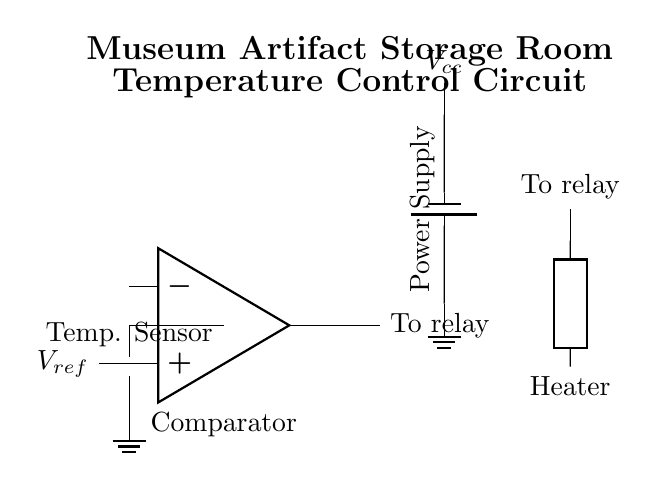What is the main function of the circuit? The circuit is designed to regulate temperature in a museum's artifact storage room, ensuring that the environmental conditions are suitable for preserving the artifacts.
Answer: Regulate temperature What type of sensor is used in this circuit? The circuit employs a thermistor as a temperature sensor, which changes resistance based on the temperature it experiences.
Answer: Thermistor What is the reference voltage designated in the circuit? The reference voltage is indicated as V ref in the circuit, which is used by the comparator to determine if the current temperature exceeds the desired threshold.
Answer: V ref What component controls the heating element? The comparator output ultimately controls the relay, which acts as a switch to turn the heating element on or off based on temperature readings.
Answer: Relay What is the role of the operational amplifier in this circuit? The operational amplifier functions as a comparator, comparing the voltage from the thermistor against the reference voltage to decide whether to activate the relay.
Answer: Comparator How many main components are present in the circuit? The key components include the thermistor, operational amplifier, relay, heating element, and power supply, amounting to five main components.
Answer: Five What is the power source type used in this circuit? The circuit utilizes a battery as the power source, providing the necessary voltage to operate the various components.
Answer: Battery 